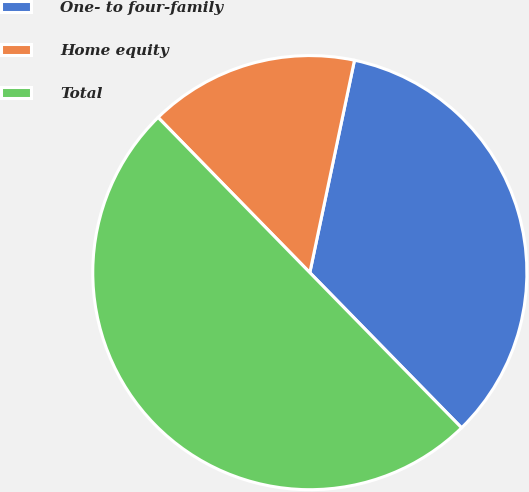<chart> <loc_0><loc_0><loc_500><loc_500><pie_chart><fcel>One- to four-family<fcel>Home equity<fcel>Total<nl><fcel>34.38%<fcel>15.62%<fcel>50.0%<nl></chart> 